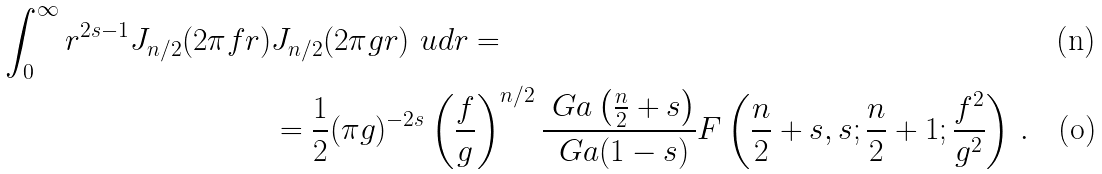<formula> <loc_0><loc_0><loc_500><loc_500>\int _ { 0 } ^ { \infty } r ^ { 2 s - 1 } J _ { n / 2 } ( 2 \pi f r ) & J _ { n / 2 } ( 2 \pi g r ) \ u d r = \\ & = \frac { 1 } { 2 } ( \pi g ) ^ { - 2 s } \left ( \frac { f } { g } \right ) ^ { n / 2 } \frac { \ G a \left ( \frac { n } { 2 } + s \right ) } { \ G a ( 1 - s ) } F \left ( \frac { n } { 2 } + s , s ; \frac { n } { 2 } + 1 ; \frac { f ^ { 2 } } { g ^ { 2 } } \right ) \, .</formula> 